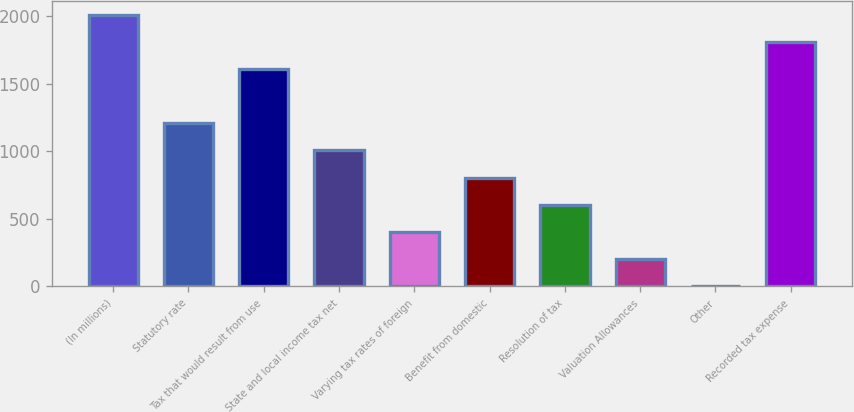Convert chart. <chart><loc_0><loc_0><loc_500><loc_500><bar_chart><fcel>(In millions)<fcel>Statutory rate<fcel>Tax that would result from use<fcel>State and local income tax net<fcel>Varying tax rates of foreign<fcel>Benefit from domestic<fcel>Resolution of tax<fcel>Valuation Allowances<fcel>Other<fcel>Recorded tax expense<nl><fcel>2010<fcel>1206.04<fcel>1608.02<fcel>1005.05<fcel>402.08<fcel>804.06<fcel>603.07<fcel>201.09<fcel>0.1<fcel>1809.01<nl></chart> 